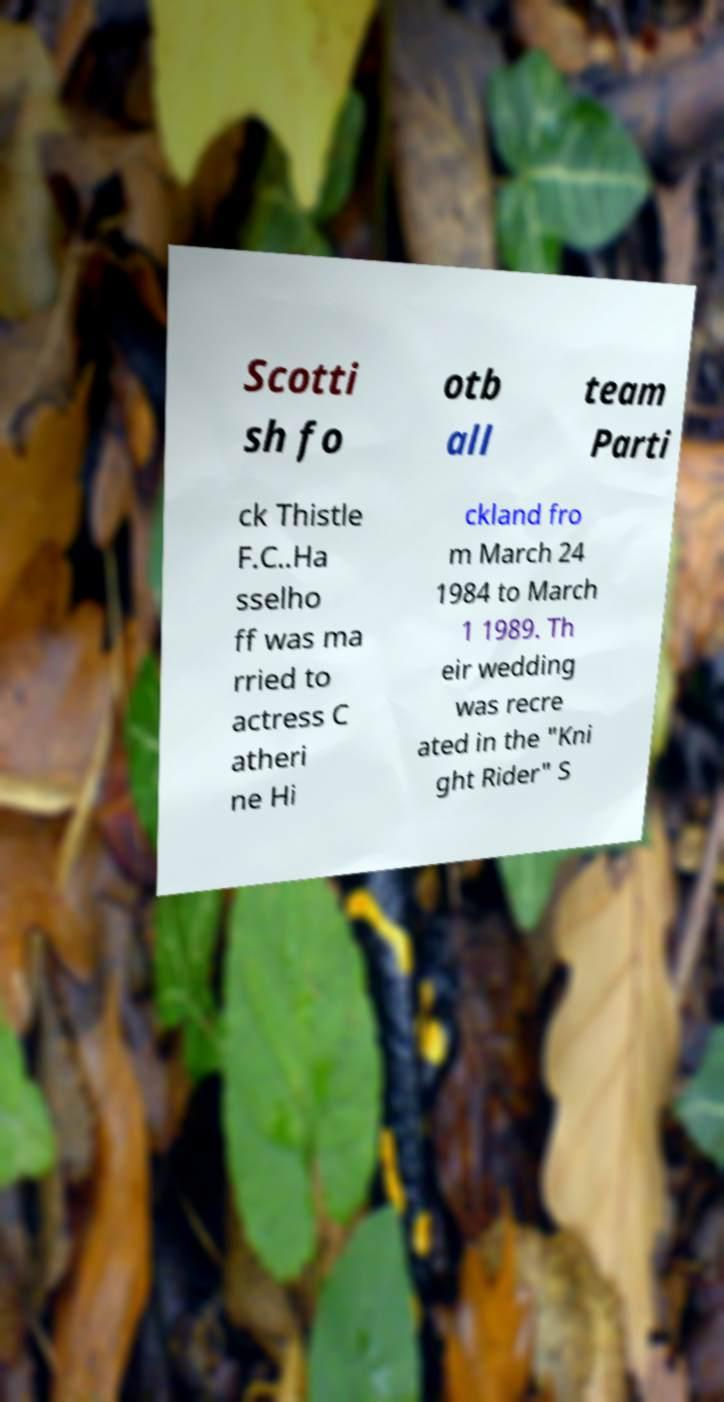Please identify and transcribe the text found in this image. Scotti sh fo otb all team Parti ck Thistle F.C..Ha sselho ff was ma rried to actress C atheri ne Hi ckland fro m March 24 1984 to March 1 1989. Th eir wedding was recre ated in the "Kni ght Rider" S 